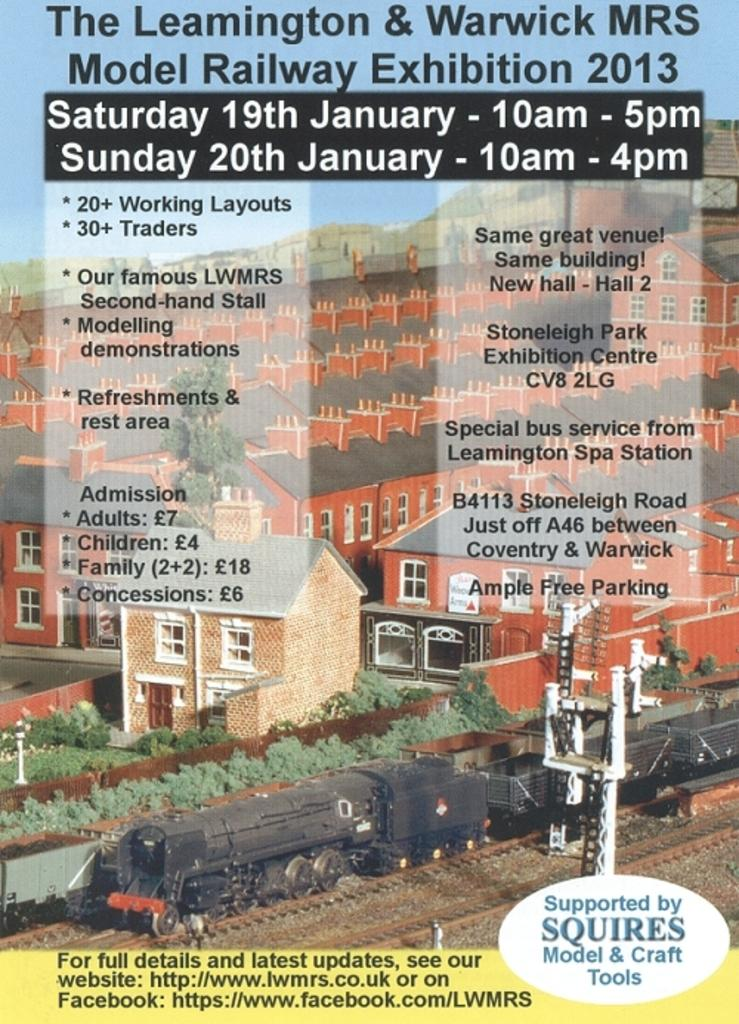<image>
Offer a succinct explanation of the picture presented. A poster for a model train exhibition with a facebook link. 